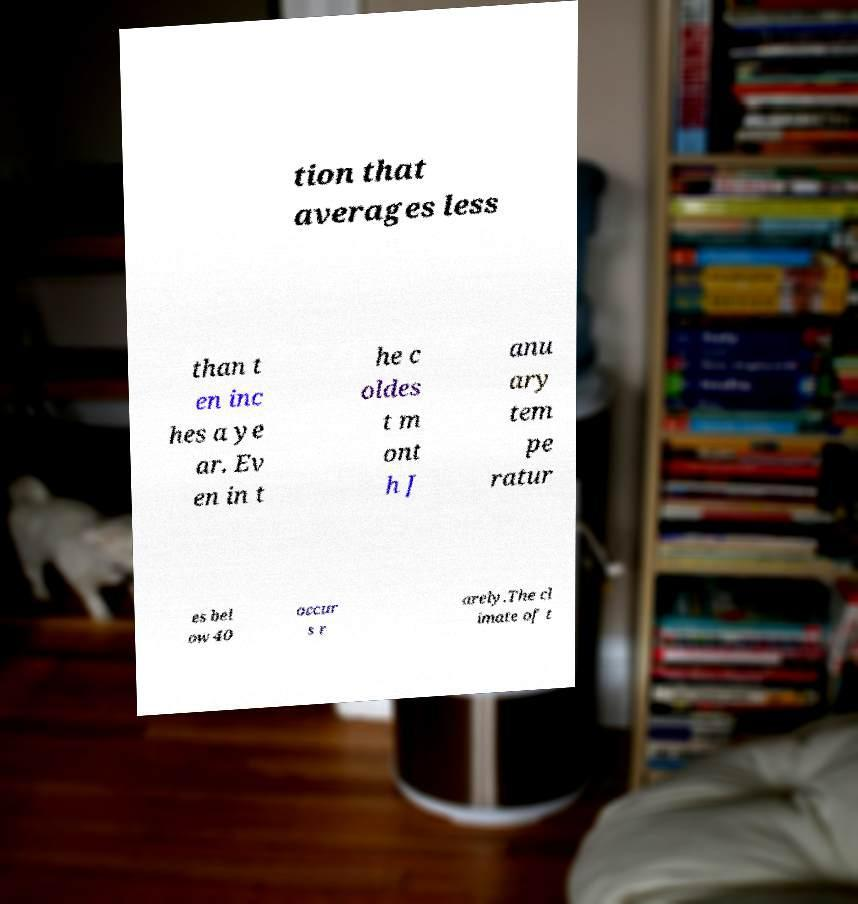Please identify and transcribe the text found in this image. tion that averages less than t en inc hes a ye ar. Ev en in t he c oldes t m ont h J anu ary tem pe ratur es bel ow 40 occur s r arely.The cl imate of t 